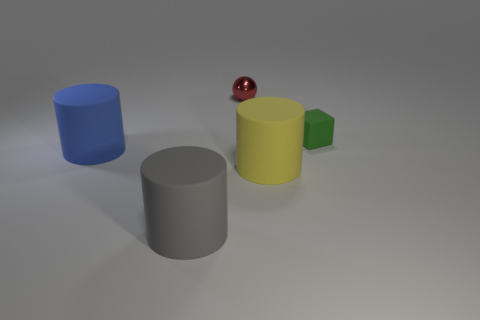What number of objects are behind the small rubber block and in front of the big blue cylinder?
Keep it short and to the point. 0. How many things are either yellow rubber cylinders or rubber things in front of the small cube?
Make the answer very short. 3. There is a rubber thing behind the blue matte cylinder; what is its color?
Offer a very short reply. Green. What number of things are big things that are to the right of the metallic thing or yellow cylinders?
Provide a short and direct response. 1. What color is the metal thing that is the same size as the green rubber object?
Provide a succinct answer. Red. Is the number of large blue rubber cylinders that are in front of the sphere greater than the number of big yellow rubber cylinders?
Keep it short and to the point. No. What is the material of the object that is behind the blue object and in front of the tiny red shiny ball?
Provide a succinct answer. Rubber. There is a tiny thing that is in front of the sphere; is its color the same as the big object that is in front of the large yellow matte cylinder?
Offer a very short reply. No. What number of other things are the same size as the gray rubber cylinder?
Ensure brevity in your answer.  2. Is there a large rubber cylinder behind the rubber object right of the cylinder to the right of the small red thing?
Keep it short and to the point. No. 